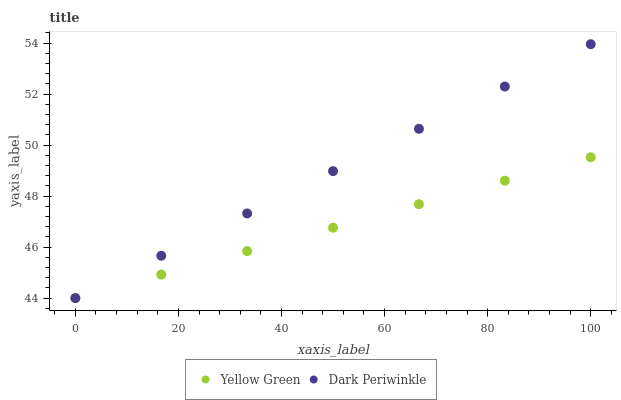Does Yellow Green have the minimum area under the curve?
Answer yes or no. Yes. Does Dark Periwinkle have the maximum area under the curve?
Answer yes or no. Yes. Does Dark Periwinkle have the minimum area under the curve?
Answer yes or no. No. Is Yellow Green the smoothest?
Answer yes or no. Yes. Is Dark Periwinkle the roughest?
Answer yes or no. Yes. Is Dark Periwinkle the smoothest?
Answer yes or no. No. Does Yellow Green have the lowest value?
Answer yes or no. Yes. Does Dark Periwinkle have the highest value?
Answer yes or no. Yes. Does Yellow Green intersect Dark Periwinkle?
Answer yes or no. Yes. Is Yellow Green less than Dark Periwinkle?
Answer yes or no. No. Is Yellow Green greater than Dark Periwinkle?
Answer yes or no. No. 